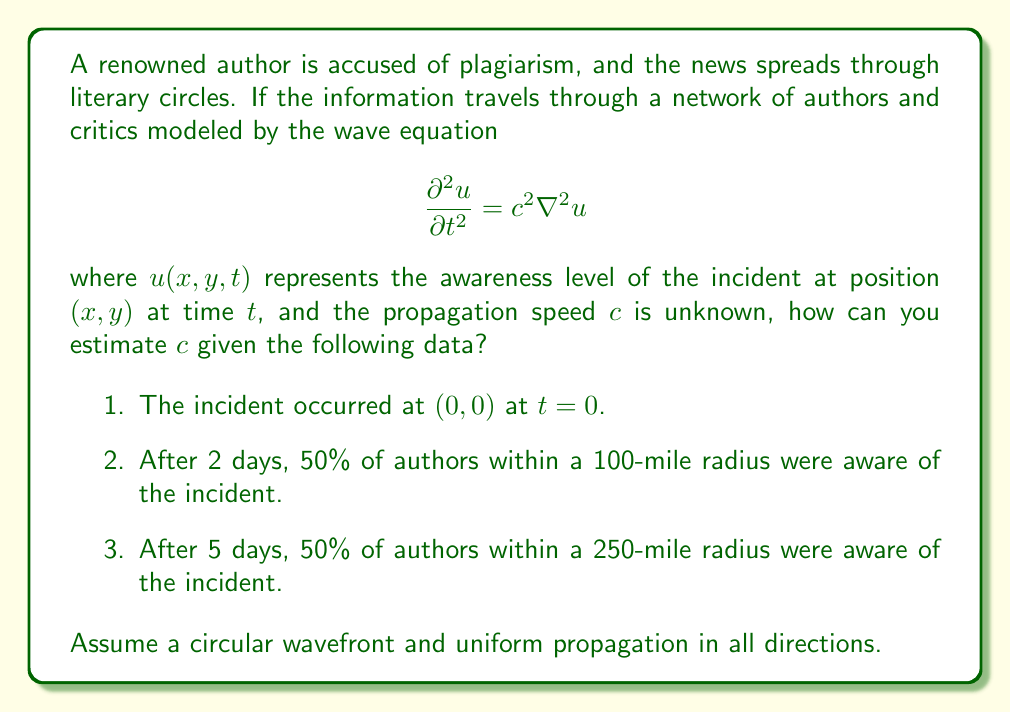Can you solve this math problem? To estimate the propagation speed $c$, we can use the concept of wavefront propagation in the wave equation:

1. In a 2D circular wavefront, the radius $r$ of the wavefront at time $t$ is given by:
   $$r = ct$$

2. We have two data points:
   - At $t_1 = 2$ days, $r_1 = 100$ miles
   - At $t_2 = 5$ days, $r_2 = 250$ miles

3. We can write two equations:
   $$r_1 = ct_1 \implies 100 = c \cdot 2$$
   $$r_2 = ct_2 \implies 250 = c \cdot 5$$

4. Solving the first equation:
   $$c = \frac{100}{2} = 50 \text{ miles/day}$$

5. Solving the second equation:
   $$c = \frac{250}{5} = 50 \text{ miles/day}$$

6. Both equations yield the same value for $c$, confirming the consistency of the data and our assumption of uniform propagation.

Therefore, the estimated propagation speed of the reputation damage in literary circles is 50 miles per day.
Answer: $c = 50 \text{ miles/day}$ 